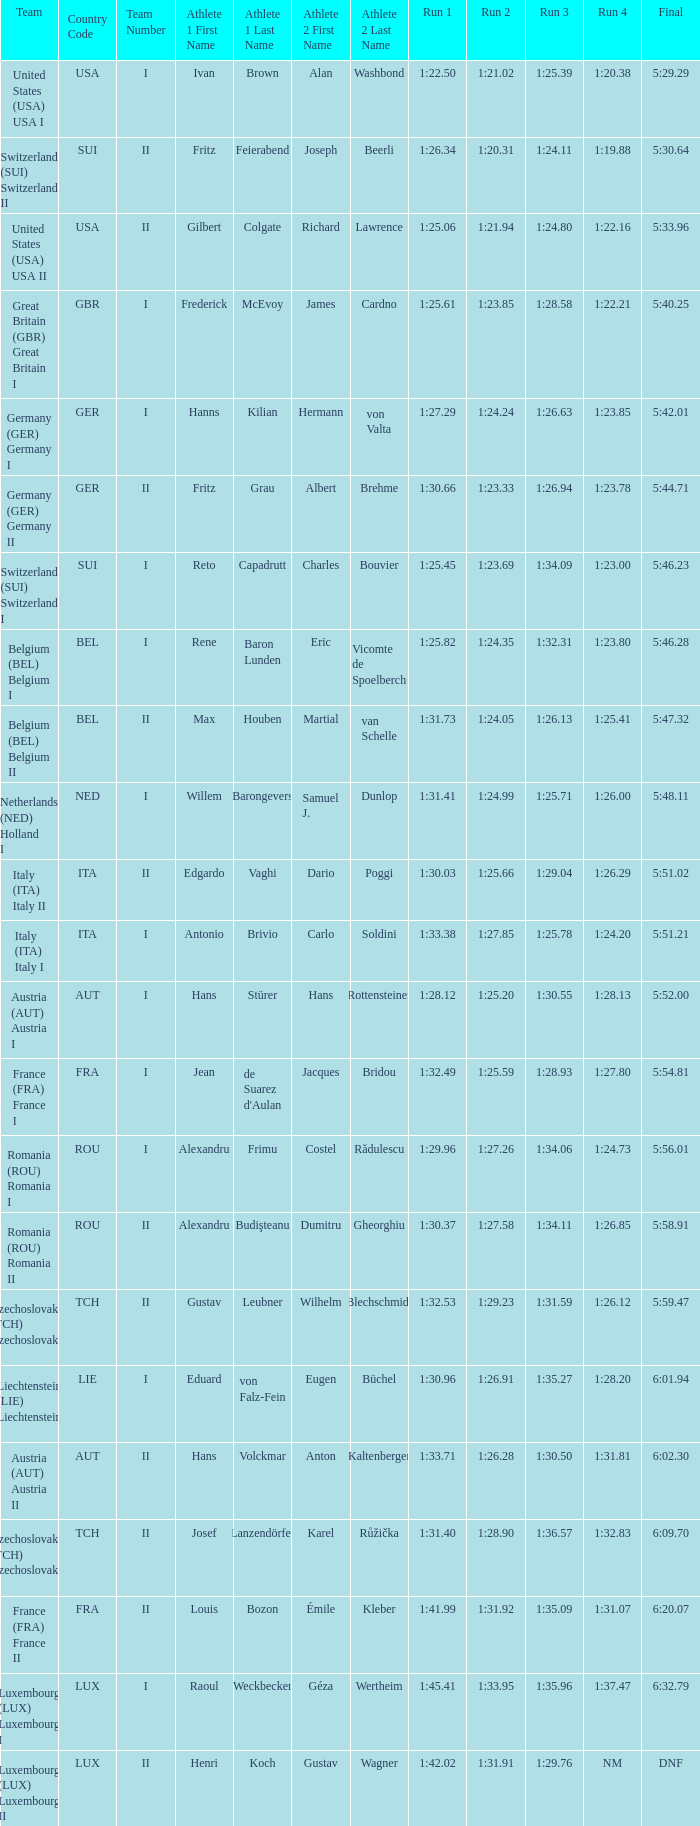03? 1:25.66. 